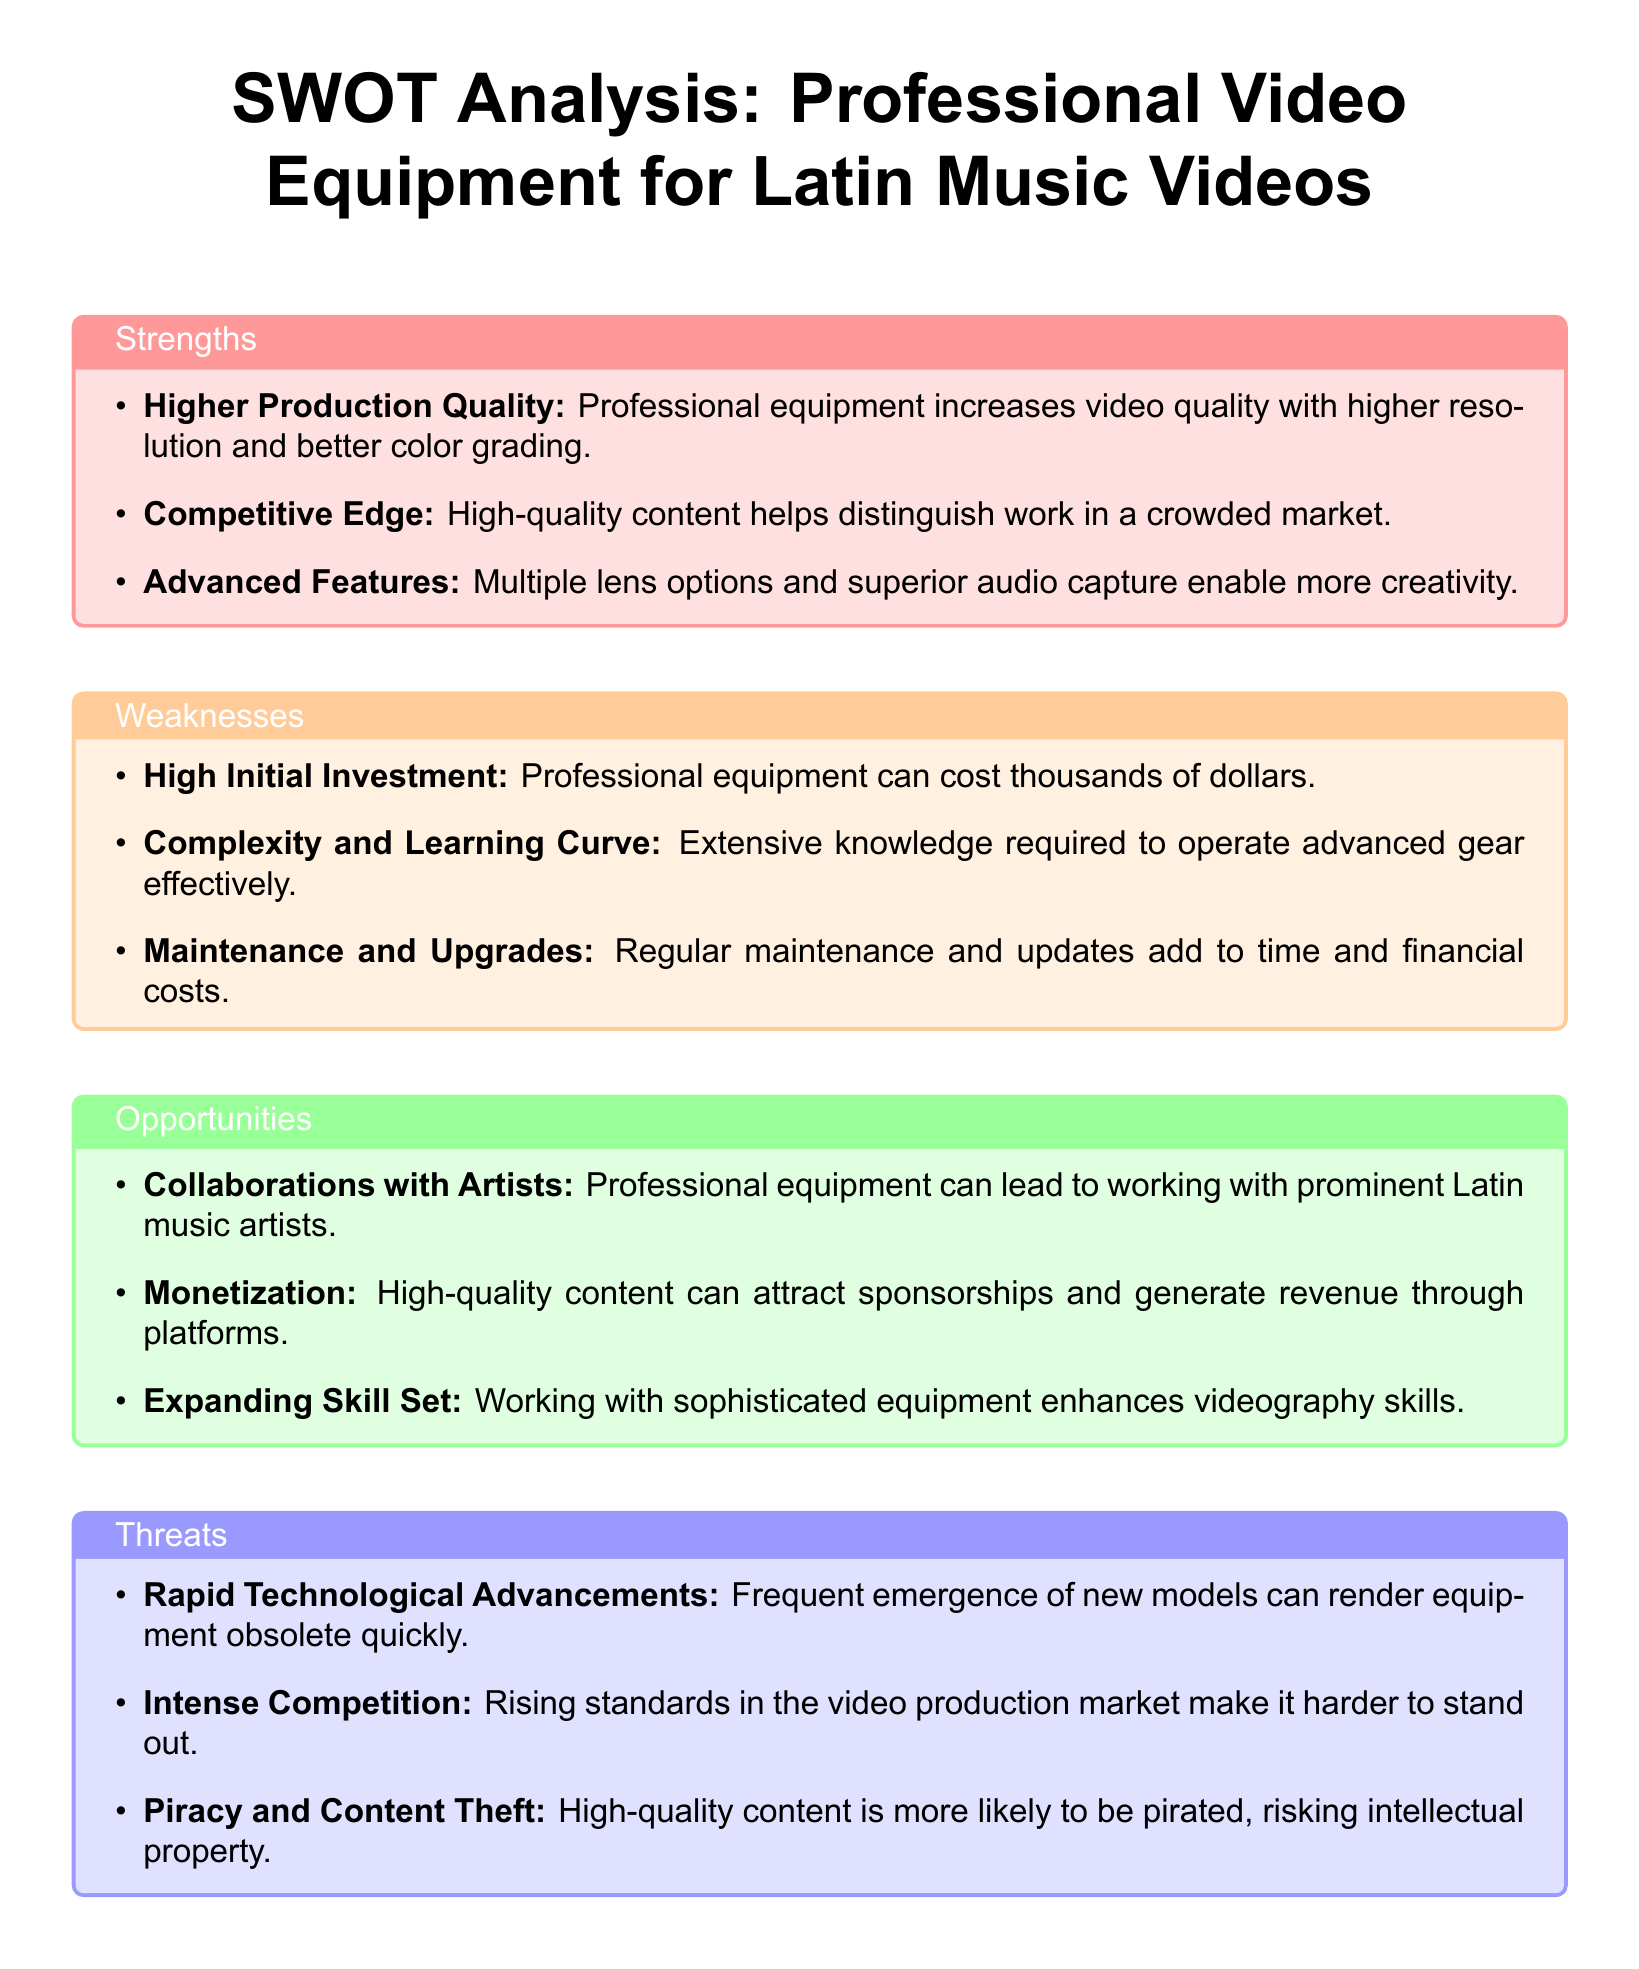What is one strength of professional video equipment? One strength listed is that professional equipment increases video quality with higher resolution and better color grading.
Answer: Higher Production Quality What is a weakness related to professional video equipment? One weakness mentioned is the high cost associated with acquiring professional equipment.
Answer: High Initial Investment What is an opportunity that comes with investing in professional video equipment? One opportunity noted is that high-quality content can attract sponsorships and generate revenue through platforms.
Answer: Monetization How many strengths are identified in the SWOT analysis? The document lists three strengths in the strengths section.
Answer: 3 What is a threat mentioned regarding content produced with professional video equipment? One threat specified is that high-quality content is more likely to be pirated, risking intellectual property.
Answer: Piracy and Content Theft What advanced feature does professional video equipment offer? Advanced features include multiple lens options and superior audio capture that enable more creativity.
Answer: Multiple lens options and superior audio capture What is a common challenge when using professional video equipment? A common challenge mentioned is the complexity and learning curve involved in operating advanced gear effectively.
Answer: Complexity and Learning Curve 